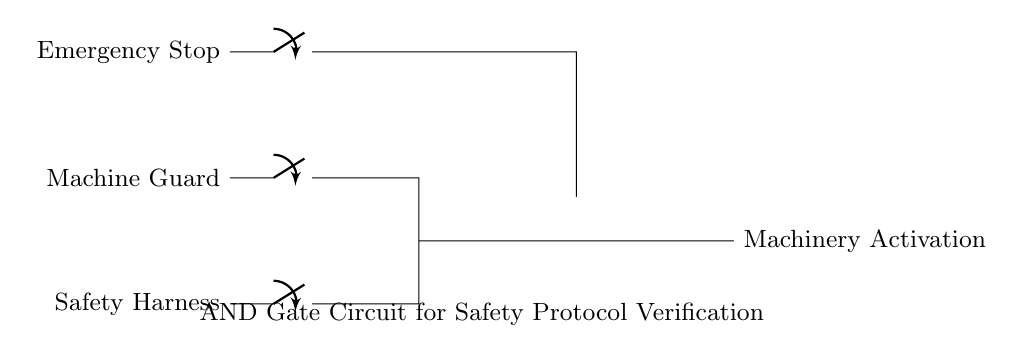What components are used in this circuit? The circuit includes safety harness, machine guard, emergency stop, switches, and an AND gate. These components are crucial for ensuring all safety protocols before activating the machinery.
Answer: safety harness, machine guard, emergency stop, switches, AND gate What is the function of the AND gate in this circuit? The AND gate functions as a safety verification mechanism, ensuring that all safety conditions (i.e., safety harness and machine guard) are met before allowing machinery activation. It requires inputs from both to output a signal for activation.
Answer: safety verification How many switches are present in the circuit? There are three switches in the circuit, controlling the safety harness, machine guard, and the emergency stop, each of which plays a role in ensuring safety.
Answer: three What condition must be met for the machinery to activate? The machinery will activate only when both the safety harness and machine guard conditions are satisfied, as indicated by the inputs to the AND gate being high.
Answer: both conditions satisfied What does the emergency stop do in this circuit? The emergency stop serves as a safety feature that can interrupt the activation process by inverting the signal, leading to a high level of safety and control in case of an emergency.
Answer: interrupts activation What is the output signal when the emergency stop is active? When the emergency stop is active, it creates a low output signal because it inverts the input signal, preventing the machinery from activating regardless of the other conditions.
Answer: low output signal 